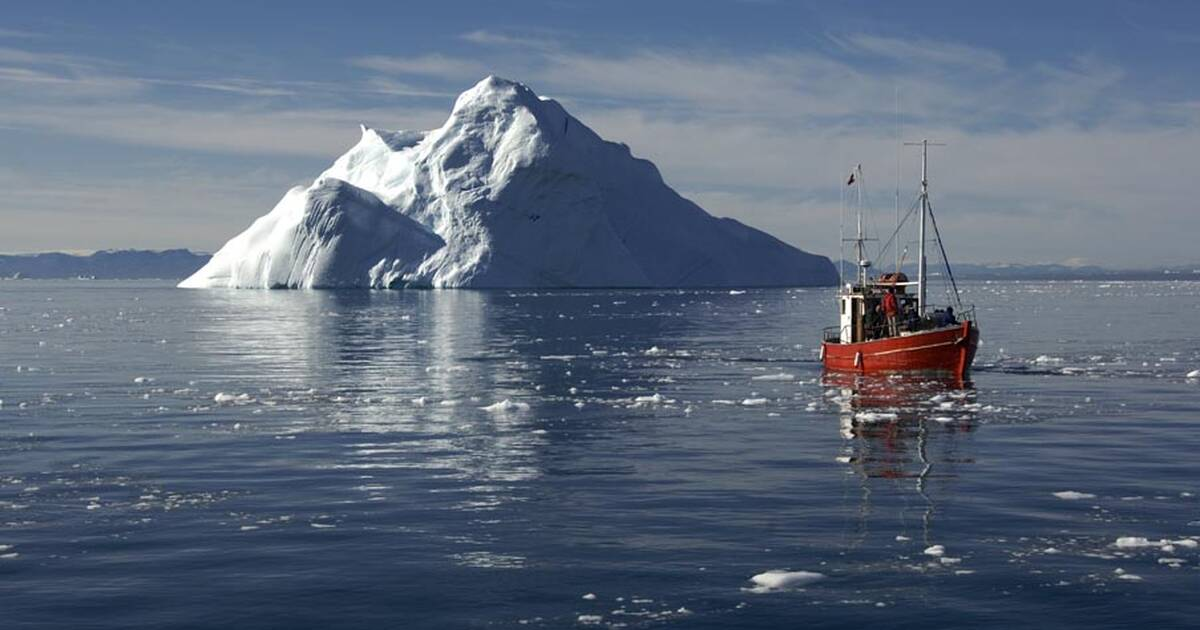Imagine a short realistic scenario involving a sudden storm hitting the fishing boat. The fishing boat Aurora was making steady progress through the calm waters of the Ilulissat Icefjord when the sky began to darken unexpectedly. Captain Lars, sensing a change in weather, ordered the crew to secure all equipment and prepare for rough seas. Within minutes, gusts of wind intensified, and the once placid waters turned tumultuous.

The storm hit with sudden ferocity, waves crashing against the hull, and visibility dropping to mere meters. The crew, seasoned but tense, worked with practiced efficiency, securing lines and ensuring that the boat's navigation systems were fully operational. Captain Lars adjusted their course to head towards a sheltered cove he knew from previous journeys.

Navigating through the churning waters, the crew held their resolve, working in synchrony to keep the boat steady. After what felt like hours, but was only a fraction of that time, they reached the relative calm of the cove. As the storm raged outside, Aurora sat anchored, safe and sound.

The tempest eventually passed, leaving behind a transformed, icy landscape. But Aurora and its crew, through skill and preparation, had withstood another Arctic challenge, adding another story to their shared history. 